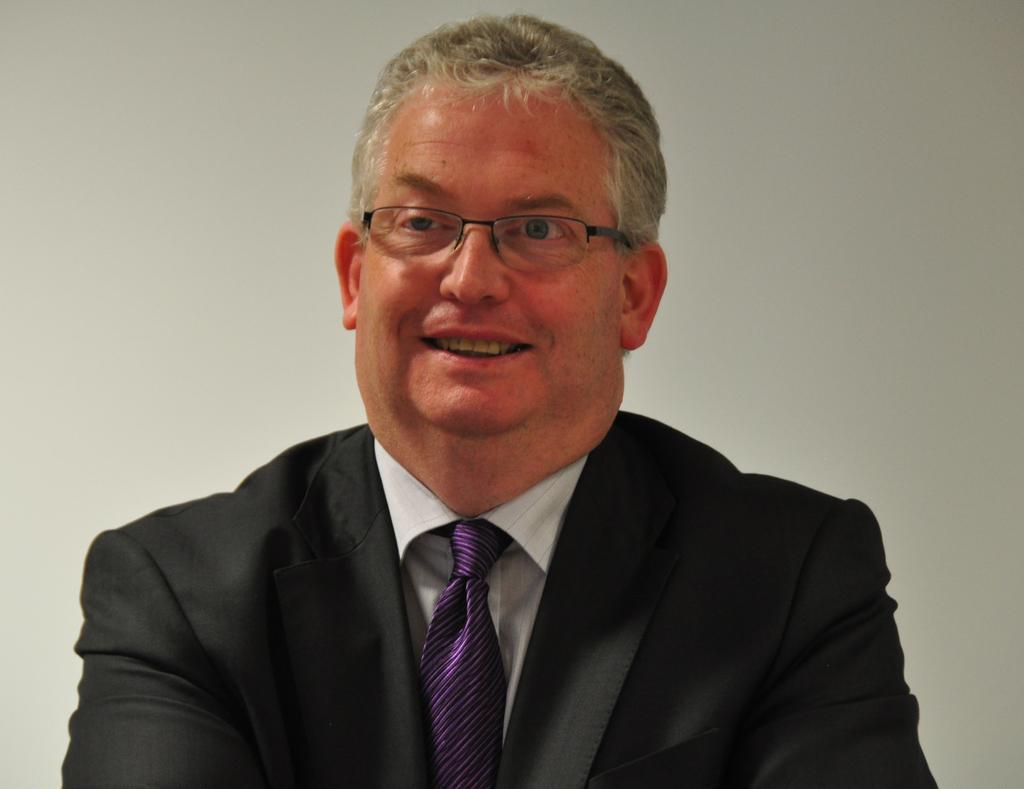In one or two sentences, can you explain what this image depicts? In this image I can see the person with black color blazer, violet color tie and the white color specs. He is also wearing the specs. In the back I can see the white wall. 